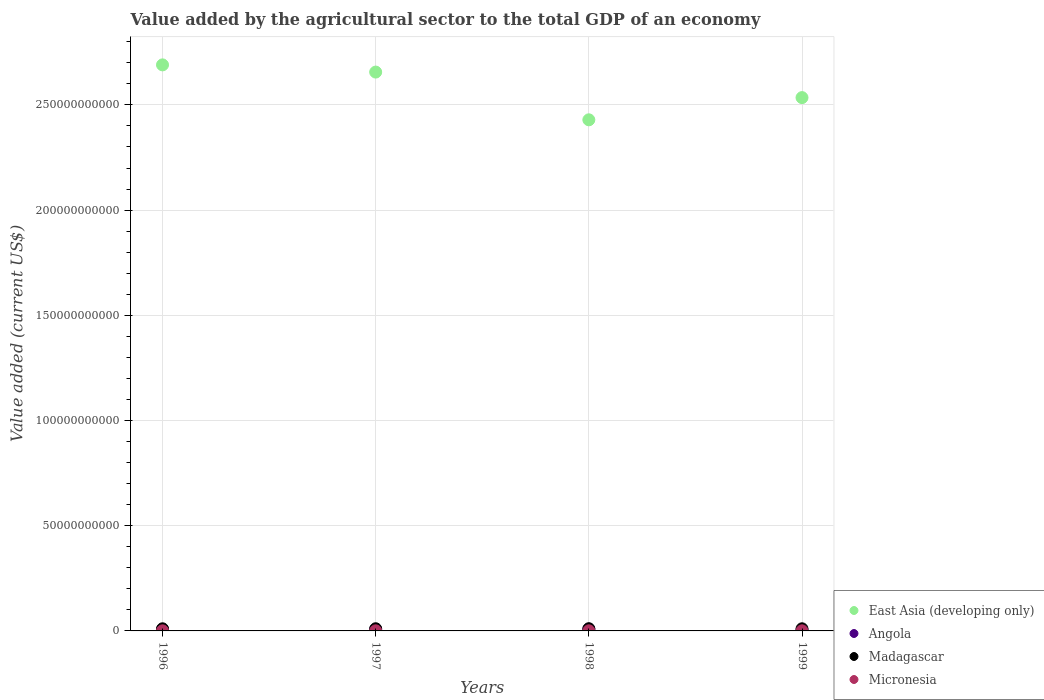How many different coloured dotlines are there?
Ensure brevity in your answer.  4. Is the number of dotlines equal to the number of legend labels?
Keep it short and to the point. Yes. What is the value added by the agricultural sector to the total GDP in Madagascar in 1996?
Keep it short and to the point. 1.01e+09. Across all years, what is the maximum value added by the agricultural sector to the total GDP in Angola?
Provide a short and direct response. 8.40e+08. Across all years, what is the minimum value added by the agricultural sector to the total GDP in East Asia (developing only)?
Give a very brief answer. 2.43e+11. In which year was the value added by the agricultural sector to the total GDP in Angola maximum?
Your answer should be compact. 1998. In which year was the value added by the agricultural sector to the total GDP in Angola minimum?
Provide a succinct answer. 1999. What is the total value added by the agricultural sector to the total GDP in Madagascar in the graph?
Provide a short and direct response. 4.11e+09. What is the difference between the value added by the agricultural sector to the total GDP in Angola in 1996 and that in 1999?
Ensure brevity in your answer.  1.42e+08. What is the difference between the value added by the agricultural sector to the total GDP in Micronesia in 1997 and the value added by the agricultural sector to the total GDP in East Asia (developing only) in 1996?
Your response must be concise. -2.69e+11. What is the average value added by the agricultural sector to the total GDP in Madagascar per year?
Offer a terse response. 1.03e+09. In the year 1998, what is the difference between the value added by the agricultural sector to the total GDP in Angola and value added by the agricultural sector to the total GDP in East Asia (developing only)?
Offer a terse response. -2.42e+11. In how many years, is the value added by the agricultural sector to the total GDP in Angola greater than 140000000000 US$?
Make the answer very short. 0. What is the ratio of the value added by the agricultural sector to the total GDP in Madagascar in 1997 to that in 1998?
Offer a very short reply. 0.98. Is the value added by the agricultural sector to the total GDP in Angola in 1997 less than that in 1998?
Ensure brevity in your answer.  Yes. What is the difference between the highest and the second highest value added by the agricultural sector to the total GDP in Angola?
Provide a short and direct response. 1.51e+08. What is the difference between the highest and the lowest value added by the agricultural sector to the total GDP in Madagascar?
Your response must be concise. 3.93e+07. In how many years, is the value added by the agricultural sector to the total GDP in Angola greater than the average value added by the agricultural sector to the total GDP in Angola taken over all years?
Make the answer very short. 2. Is it the case that in every year, the sum of the value added by the agricultural sector to the total GDP in Madagascar and value added by the agricultural sector to the total GDP in Micronesia  is greater than the sum of value added by the agricultural sector to the total GDP in Angola and value added by the agricultural sector to the total GDP in East Asia (developing only)?
Your answer should be very brief. No. Is it the case that in every year, the sum of the value added by the agricultural sector to the total GDP in Angola and value added by the agricultural sector to the total GDP in Madagascar  is greater than the value added by the agricultural sector to the total GDP in East Asia (developing only)?
Your answer should be very brief. No. Is the value added by the agricultural sector to the total GDP in Angola strictly less than the value added by the agricultural sector to the total GDP in Micronesia over the years?
Provide a succinct answer. No. How many dotlines are there?
Offer a very short reply. 4. Does the graph contain any zero values?
Give a very brief answer. No. Does the graph contain grids?
Offer a very short reply. Yes. Where does the legend appear in the graph?
Make the answer very short. Bottom right. How many legend labels are there?
Your answer should be very brief. 4. What is the title of the graph?
Offer a very short reply. Value added by the agricultural sector to the total GDP of an economy. Does "Honduras" appear as one of the legend labels in the graph?
Give a very brief answer. No. What is the label or title of the Y-axis?
Offer a very short reply. Value added (current US$). What is the Value added (current US$) of East Asia (developing only) in 1996?
Your answer should be compact. 2.69e+11. What is the Value added (current US$) in Angola in 1996?
Provide a short and direct response. 5.29e+08. What is the Value added (current US$) in Madagascar in 1996?
Make the answer very short. 1.01e+09. What is the Value added (current US$) in Micronesia in 1996?
Provide a short and direct response. 5.15e+07. What is the Value added (current US$) of East Asia (developing only) in 1997?
Your answer should be very brief. 2.66e+11. What is the Value added (current US$) in Angola in 1997?
Provide a succinct answer. 6.89e+08. What is the Value added (current US$) of Madagascar in 1997?
Offer a very short reply. 1.03e+09. What is the Value added (current US$) of Micronesia in 1997?
Provide a short and direct response. 4.81e+07. What is the Value added (current US$) in East Asia (developing only) in 1998?
Provide a short and direct response. 2.43e+11. What is the Value added (current US$) of Angola in 1998?
Offer a terse response. 8.40e+08. What is the Value added (current US$) of Madagascar in 1998?
Offer a very short reply. 1.05e+09. What is the Value added (current US$) of Micronesia in 1998?
Your answer should be very brief. 5.61e+07. What is the Value added (current US$) in East Asia (developing only) in 1999?
Your answer should be very brief. 2.53e+11. What is the Value added (current US$) of Angola in 1999?
Offer a terse response. 3.87e+08. What is the Value added (current US$) of Madagascar in 1999?
Your response must be concise. 1.01e+09. What is the Value added (current US$) in Micronesia in 1999?
Provide a succinct answer. 5.26e+07. Across all years, what is the maximum Value added (current US$) of East Asia (developing only)?
Give a very brief answer. 2.69e+11. Across all years, what is the maximum Value added (current US$) of Angola?
Your answer should be very brief. 8.40e+08. Across all years, what is the maximum Value added (current US$) in Madagascar?
Offer a terse response. 1.05e+09. Across all years, what is the maximum Value added (current US$) in Micronesia?
Offer a very short reply. 5.61e+07. Across all years, what is the minimum Value added (current US$) in East Asia (developing only)?
Your response must be concise. 2.43e+11. Across all years, what is the minimum Value added (current US$) of Angola?
Provide a short and direct response. 3.87e+08. Across all years, what is the minimum Value added (current US$) of Madagascar?
Keep it short and to the point. 1.01e+09. Across all years, what is the minimum Value added (current US$) of Micronesia?
Offer a terse response. 4.81e+07. What is the total Value added (current US$) of East Asia (developing only) in the graph?
Provide a succinct answer. 1.03e+12. What is the total Value added (current US$) in Angola in the graph?
Your response must be concise. 2.44e+09. What is the total Value added (current US$) in Madagascar in the graph?
Provide a short and direct response. 4.11e+09. What is the total Value added (current US$) of Micronesia in the graph?
Ensure brevity in your answer.  2.08e+08. What is the difference between the Value added (current US$) in East Asia (developing only) in 1996 and that in 1997?
Offer a very short reply. 3.42e+09. What is the difference between the Value added (current US$) of Angola in 1996 and that in 1997?
Your answer should be compact. -1.60e+08. What is the difference between the Value added (current US$) of Madagascar in 1996 and that in 1997?
Give a very brief answer. -2.26e+07. What is the difference between the Value added (current US$) in Micronesia in 1996 and that in 1997?
Keep it short and to the point. 3.49e+06. What is the difference between the Value added (current US$) of East Asia (developing only) in 1996 and that in 1998?
Keep it short and to the point. 2.61e+1. What is the difference between the Value added (current US$) of Angola in 1996 and that in 1998?
Provide a succinct answer. -3.11e+08. What is the difference between the Value added (current US$) in Madagascar in 1996 and that in 1998?
Offer a very short reply. -3.93e+07. What is the difference between the Value added (current US$) of Micronesia in 1996 and that in 1998?
Your response must be concise. -4.51e+06. What is the difference between the Value added (current US$) in East Asia (developing only) in 1996 and that in 1999?
Your answer should be very brief. 1.56e+1. What is the difference between the Value added (current US$) in Angola in 1996 and that in 1999?
Your response must be concise. 1.42e+08. What is the difference between the Value added (current US$) of Madagascar in 1996 and that in 1999?
Your response must be concise. -1.27e+06. What is the difference between the Value added (current US$) in Micronesia in 1996 and that in 1999?
Keep it short and to the point. -1.06e+06. What is the difference between the Value added (current US$) of East Asia (developing only) in 1997 and that in 1998?
Your answer should be very brief. 2.27e+1. What is the difference between the Value added (current US$) of Angola in 1997 and that in 1998?
Make the answer very short. -1.51e+08. What is the difference between the Value added (current US$) of Madagascar in 1997 and that in 1998?
Provide a short and direct response. -1.66e+07. What is the difference between the Value added (current US$) in Micronesia in 1997 and that in 1998?
Ensure brevity in your answer.  -8.00e+06. What is the difference between the Value added (current US$) of East Asia (developing only) in 1997 and that in 1999?
Ensure brevity in your answer.  1.21e+1. What is the difference between the Value added (current US$) in Angola in 1997 and that in 1999?
Your answer should be very brief. 3.02e+08. What is the difference between the Value added (current US$) of Madagascar in 1997 and that in 1999?
Your response must be concise. 2.13e+07. What is the difference between the Value added (current US$) of Micronesia in 1997 and that in 1999?
Your answer should be very brief. -4.55e+06. What is the difference between the Value added (current US$) in East Asia (developing only) in 1998 and that in 1999?
Your answer should be very brief. -1.06e+1. What is the difference between the Value added (current US$) in Angola in 1998 and that in 1999?
Make the answer very short. 4.53e+08. What is the difference between the Value added (current US$) in Madagascar in 1998 and that in 1999?
Keep it short and to the point. 3.80e+07. What is the difference between the Value added (current US$) of Micronesia in 1998 and that in 1999?
Your response must be concise. 3.45e+06. What is the difference between the Value added (current US$) in East Asia (developing only) in 1996 and the Value added (current US$) in Angola in 1997?
Ensure brevity in your answer.  2.68e+11. What is the difference between the Value added (current US$) in East Asia (developing only) in 1996 and the Value added (current US$) in Madagascar in 1997?
Your response must be concise. 2.68e+11. What is the difference between the Value added (current US$) in East Asia (developing only) in 1996 and the Value added (current US$) in Micronesia in 1997?
Offer a very short reply. 2.69e+11. What is the difference between the Value added (current US$) of Angola in 1996 and the Value added (current US$) of Madagascar in 1997?
Give a very brief answer. -5.06e+08. What is the difference between the Value added (current US$) in Angola in 1996 and the Value added (current US$) in Micronesia in 1997?
Make the answer very short. 4.81e+08. What is the difference between the Value added (current US$) in Madagascar in 1996 and the Value added (current US$) in Micronesia in 1997?
Your response must be concise. 9.64e+08. What is the difference between the Value added (current US$) in East Asia (developing only) in 1996 and the Value added (current US$) in Angola in 1998?
Your response must be concise. 2.68e+11. What is the difference between the Value added (current US$) of East Asia (developing only) in 1996 and the Value added (current US$) of Madagascar in 1998?
Keep it short and to the point. 2.68e+11. What is the difference between the Value added (current US$) in East Asia (developing only) in 1996 and the Value added (current US$) in Micronesia in 1998?
Keep it short and to the point. 2.69e+11. What is the difference between the Value added (current US$) of Angola in 1996 and the Value added (current US$) of Madagascar in 1998?
Keep it short and to the point. -5.22e+08. What is the difference between the Value added (current US$) of Angola in 1996 and the Value added (current US$) of Micronesia in 1998?
Your response must be concise. 4.73e+08. What is the difference between the Value added (current US$) in Madagascar in 1996 and the Value added (current US$) in Micronesia in 1998?
Your answer should be very brief. 9.56e+08. What is the difference between the Value added (current US$) in East Asia (developing only) in 1996 and the Value added (current US$) in Angola in 1999?
Your answer should be compact. 2.69e+11. What is the difference between the Value added (current US$) of East Asia (developing only) in 1996 and the Value added (current US$) of Madagascar in 1999?
Your answer should be very brief. 2.68e+11. What is the difference between the Value added (current US$) in East Asia (developing only) in 1996 and the Value added (current US$) in Micronesia in 1999?
Provide a succinct answer. 2.69e+11. What is the difference between the Value added (current US$) in Angola in 1996 and the Value added (current US$) in Madagascar in 1999?
Ensure brevity in your answer.  -4.84e+08. What is the difference between the Value added (current US$) of Angola in 1996 and the Value added (current US$) of Micronesia in 1999?
Ensure brevity in your answer.  4.76e+08. What is the difference between the Value added (current US$) of Madagascar in 1996 and the Value added (current US$) of Micronesia in 1999?
Make the answer very short. 9.59e+08. What is the difference between the Value added (current US$) of East Asia (developing only) in 1997 and the Value added (current US$) of Angola in 1998?
Provide a short and direct response. 2.65e+11. What is the difference between the Value added (current US$) in East Asia (developing only) in 1997 and the Value added (current US$) in Madagascar in 1998?
Your response must be concise. 2.65e+11. What is the difference between the Value added (current US$) in East Asia (developing only) in 1997 and the Value added (current US$) in Micronesia in 1998?
Your answer should be very brief. 2.66e+11. What is the difference between the Value added (current US$) of Angola in 1997 and the Value added (current US$) of Madagascar in 1998?
Your response must be concise. -3.62e+08. What is the difference between the Value added (current US$) in Angola in 1997 and the Value added (current US$) in Micronesia in 1998?
Your answer should be very brief. 6.33e+08. What is the difference between the Value added (current US$) in Madagascar in 1997 and the Value added (current US$) in Micronesia in 1998?
Your response must be concise. 9.78e+08. What is the difference between the Value added (current US$) of East Asia (developing only) in 1997 and the Value added (current US$) of Angola in 1999?
Give a very brief answer. 2.65e+11. What is the difference between the Value added (current US$) in East Asia (developing only) in 1997 and the Value added (current US$) in Madagascar in 1999?
Offer a terse response. 2.65e+11. What is the difference between the Value added (current US$) in East Asia (developing only) in 1997 and the Value added (current US$) in Micronesia in 1999?
Offer a very short reply. 2.66e+11. What is the difference between the Value added (current US$) of Angola in 1997 and the Value added (current US$) of Madagascar in 1999?
Your answer should be very brief. -3.24e+08. What is the difference between the Value added (current US$) of Angola in 1997 and the Value added (current US$) of Micronesia in 1999?
Provide a short and direct response. 6.36e+08. What is the difference between the Value added (current US$) in Madagascar in 1997 and the Value added (current US$) in Micronesia in 1999?
Make the answer very short. 9.82e+08. What is the difference between the Value added (current US$) of East Asia (developing only) in 1998 and the Value added (current US$) of Angola in 1999?
Your answer should be compact. 2.43e+11. What is the difference between the Value added (current US$) of East Asia (developing only) in 1998 and the Value added (current US$) of Madagascar in 1999?
Provide a short and direct response. 2.42e+11. What is the difference between the Value added (current US$) in East Asia (developing only) in 1998 and the Value added (current US$) in Micronesia in 1999?
Offer a very short reply. 2.43e+11. What is the difference between the Value added (current US$) in Angola in 1998 and the Value added (current US$) in Madagascar in 1999?
Offer a very short reply. -1.73e+08. What is the difference between the Value added (current US$) of Angola in 1998 and the Value added (current US$) of Micronesia in 1999?
Give a very brief answer. 7.87e+08. What is the difference between the Value added (current US$) of Madagascar in 1998 and the Value added (current US$) of Micronesia in 1999?
Offer a terse response. 9.99e+08. What is the average Value added (current US$) in East Asia (developing only) per year?
Ensure brevity in your answer.  2.58e+11. What is the average Value added (current US$) of Angola per year?
Offer a very short reply. 6.11e+08. What is the average Value added (current US$) in Madagascar per year?
Provide a succinct answer. 1.03e+09. What is the average Value added (current US$) in Micronesia per year?
Ensure brevity in your answer.  5.21e+07. In the year 1996, what is the difference between the Value added (current US$) in East Asia (developing only) and Value added (current US$) in Angola?
Your response must be concise. 2.68e+11. In the year 1996, what is the difference between the Value added (current US$) of East Asia (developing only) and Value added (current US$) of Madagascar?
Your response must be concise. 2.68e+11. In the year 1996, what is the difference between the Value added (current US$) in East Asia (developing only) and Value added (current US$) in Micronesia?
Make the answer very short. 2.69e+11. In the year 1996, what is the difference between the Value added (current US$) in Angola and Value added (current US$) in Madagascar?
Your answer should be very brief. -4.83e+08. In the year 1996, what is the difference between the Value added (current US$) of Angola and Value added (current US$) of Micronesia?
Make the answer very short. 4.77e+08. In the year 1996, what is the difference between the Value added (current US$) of Madagascar and Value added (current US$) of Micronesia?
Offer a terse response. 9.60e+08. In the year 1997, what is the difference between the Value added (current US$) in East Asia (developing only) and Value added (current US$) in Angola?
Provide a succinct answer. 2.65e+11. In the year 1997, what is the difference between the Value added (current US$) in East Asia (developing only) and Value added (current US$) in Madagascar?
Your answer should be very brief. 2.65e+11. In the year 1997, what is the difference between the Value added (current US$) in East Asia (developing only) and Value added (current US$) in Micronesia?
Offer a very short reply. 2.66e+11. In the year 1997, what is the difference between the Value added (current US$) in Angola and Value added (current US$) in Madagascar?
Your answer should be very brief. -3.46e+08. In the year 1997, what is the difference between the Value added (current US$) of Angola and Value added (current US$) of Micronesia?
Offer a very short reply. 6.41e+08. In the year 1997, what is the difference between the Value added (current US$) in Madagascar and Value added (current US$) in Micronesia?
Your response must be concise. 9.86e+08. In the year 1998, what is the difference between the Value added (current US$) of East Asia (developing only) and Value added (current US$) of Angola?
Offer a terse response. 2.42e+11. In the year 1998, what is the difference between the Value added (current US$) in East Asia (developing only) and Value added (current US$) in Madagascar?
Offer a terse response. 2.42e+11. In the year 1998, what is the difference between the Value added (current US$) in East Asia (developing only) and Value added (current US$) in Micronesia?
Offer a very short reply. 2.43e+11. In the year 1998, what is the difference between the Value added (current US$) of Angola and Value added (current US$) of Madagascar?
Your answer should be very brief. -2.11e+08. In the year 1998, what is the difference between the Value added (current US$) of Angola and Value added (current US$) of Micronesia?
Offer a terse response. 7.84e+08. In the year 1998, what is the difference between the Value added (current US$) of Madagascar and Value added (current US$) of Micronesia?
Ensure brevity in your answer.  9.95e+08. In the year 1999, what is the difference between the Value added (current US$) of East Asia (developing only) and Value added (current US$) of Angola?
Provide a succinct answer. 2.53e+11. In the year 1999, what is the difference between the Value added (current US$) in East Asia (developing only) and Value added (current US$) in Madagascar?
Make the answer very short. 2.52e+11. In the year 1999, what is the difference between the Value added (current US$) in East Asia (developing only) and Value added (current US$) in Micronesia?
Your answer should be very brief. 2.53e+11. In the year 1999, what is the difference between the Value added (current US$) of Angola and Value added (current US$) of Madagascar?
Your answer should be compact. -6.26e+08. In the year 1999, what is the difference between the Value added (current US$) in Angola and Value added (current US$) in Micronesia?
Your answer should be very brief. 3.34e+08. In the year 1999, what is the difference between the Value added (current US$) in Madagascar and Value added (current US$) in Micronesia?
Offer a very short reply. 9.61e+08. What is the ratio of the Value added (current US$) of East Asia (developing only) in 1996 to that in 1997?
Your response must be concise. 1.01. What is the ratio of the Value added (current US$) of Angola in 1996 to that in 1997?
Give a very brief answer. 0.77. What is the ratio of the Value added (current US$) of Madagascar in 1996 to that in 1997?
Provide a succinct answer. 0.98. What is the ratio of the Value added (current US$) of Micronesia in 1996 to that in 1997?
Make the answer very short. 1.07. What is the ratio of the Value added (current US$) of East Asia (developing only) in 1996 to that in 1998?
Your response must be concise. 1.11. What is the ratio of the Value added (current US$) in Angola in 1996 to that in 1998?
Offer a terse response. 0.63. What is the ratio of the Value added (current US$) in Madagascar in 1996 to that in 1998?
Keep it short and to the point. 0.96. What is the ratio of the Value added (current US$) in Micronesia in 1996 to that in 1998?
Offer a terse response. 0.92. What is the ratio of the Value added (current US$) in East Asia (developing only) in 1996 to that in 1999?
Your answer should be very brief. 1.06. What is the ratio of the Value added (current US$) in Angola in 1996 to that in 1999?
Give a very brief answer. 1.37. What is the ratio of the Value added (current US$) of Madagascar in 1996 to that in 1999?
Your answer should be compact. 1. What is the ratio of the Value added (current US$) in Micronesia in 1996 to that in 1999?
Give a very brief answer. 0.98. What is the ratio of the Value added (current US$) in East Asia (developing only) in 1997 to that in 1998?
Keep it short and to the point. 1.09. What is the ratio of the Value added (current US$) in Angola in 1997 to that in 1998?
Your answer should be compact. 0.82. What is the ratio of the Value added (current US$) in Madagascar in 1997 to that in 1998?
Provide a succinct answer. 0.98. What is the ratio of the Value added (current US$) in Micronesia in 1997 to that in 1998?
Offer a terse response. 0.86. What is the ratio of the Value added (current US$) of East Asia (developing only) in 1997 to that in 1999?
Offer a very short reply. 1.05. What is the ratio of the Value added (current US$) of Angola in 1997 to that in 1999?
Offer a very short reply. 1.78. What is the ratio of the Value added (current US$) of Madagascar in 1997 to that in 1999?
Keep it short and to the point. 1.02. What is the ratio of the Value added (current US$) in Micronesia in 1997 to that in 1999?
Provide a short and direct response. 0.91. What is the ratio of the Value added (current US$) in East Asia (developing only) in 1998 to that in 1999?
Provide a short and direct response. 0.96. What is the ratio of the Value added (current US$) in Angola in 1998 to that in 1999?
Offer a very short reply. 2.17. What is the ratio of the Value added (current US$) in Madagascar in 1998 to that in 1999?
Your answer should be very brief. 1.04. What is the ratio of the Value added (current US$) of Micronesia in 1998 to that in 1999?
Ensure brevity in your answer.  1.07. What is the difference between the highest and the second highest Value added (current US$) in East Asia (developing only)?
Offer a terse response. 3.42e+09. What is the difference between the highest and the second highest Value added (current US$) in Angola?
Offer a terse response. 1.51e+08. What is the difference between the highest and the second highest Value added (current US$) in Madagascar?
Make the answer very short. 1.66e+07. What is the difference between the highest and the second highest Value added (current US$) of Micronesia?
Make the answer very short. 3.45e+06. What is the difference between the highest and the lowest Value added (current US$) of East Asia (developing only)?
Keep it short and to the point. 2.61e+1. What is the difference between the highest and the lowest Value added (current US$) in Angola?
Your response must be concise. 4.53e+08. What is the difference between the highest and the lowest Value added (current US$) in Madagascar?
Provide a succinct answer. 3.93e+07. What is the difference between the highest and the lowest Value added (current US$) of Micronesia?
Provide a succinct answer. 8.00e+06. 